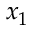Convert formula to latex. <formula><loc_0><loc_0><loc_500><loc_500>x _ { 1 }</formula> 